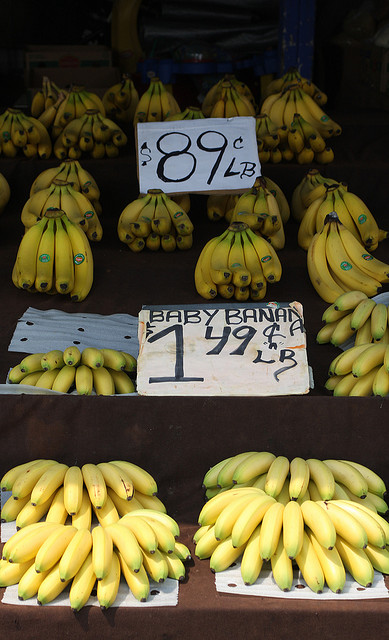Please extract the text content from this image. 89 LB BABY BANAN 1 A 9 L B 49 